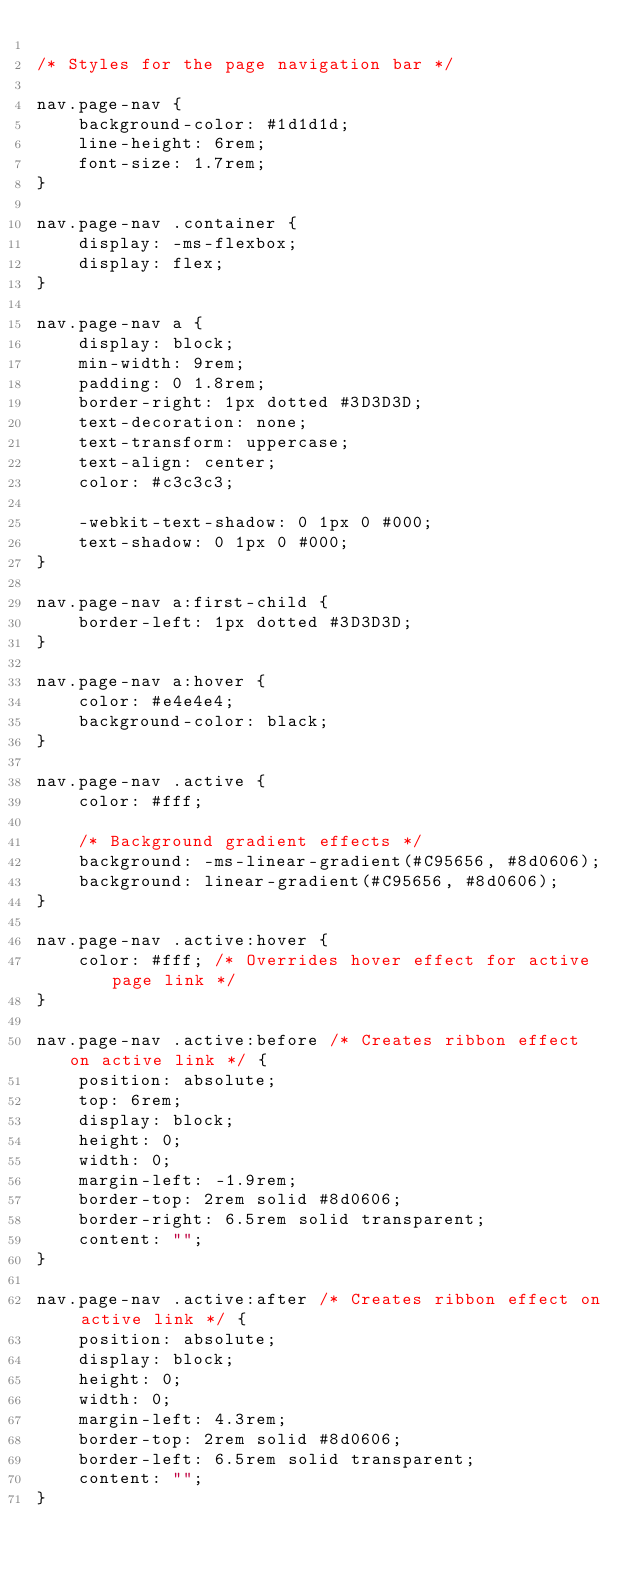<code> <loc_0><loc_0><loc_500><loc_500><_CSS_>
/* Styles for the page navigation bar */

nav.page-nav {
    background-color: #1d1d1d;
    line-height: 6rem;
    font-size: 1.7rem;
}

nav.page-nav .container {
    display: -ms-flexbox;
    display: flex;
}

nav.page-nav a {
    display: block;
    min-width: 9rem;
    padding: 0 1.8rem;
    border-right: 1px dotted #3D3D3D;
    text-decoration: none;
    text-transform: uppercase;
    text-align: center;
    color: #c3c3c3;

    -webkit-text-shadow: 0 1px 0 #000;
    text-shadow: 0 1px 0 #000;
}

nav.page-nav a:first-child {
    border-left: 1px dotted #3D3D3D;
}

nav.page-nav a:hover {
    color: #e4e4e4;
    background-color: black;
}

nav.page-nav .active {
    color: #fff;

    /* Background gradient effects */
    background: -ms-linear-gradient(#C95656, #8d0606);
    background: linear-gradient(#C95656, #8d0606);
}

nav.page-nav .active:hover {
    color: #fff; /* Overrides hover effect for active page link */
}

nav.page-nav .active:before /* Creates ribbon effect on active link */ {
    position: absolute;
    top: 6rem;
    display: block;
    height: 0;
    width: 0;
    margin-left: -1.9rem;
    border-top: 2rem solid #8d0606;
    border-right: 6.5rem solid transparent;
    content: "";
}

nav.page-nav .active:after /* Creates ribbon effect on active link */ {
    position: absolute;
    display: block;
    height: 0;
    width: 0;
    margin-left: 4.3rem;
    border-top: 2rem solid #8d0606;
    border-left: 6.5rem solid transparent;
    content: "";
}
</code> 